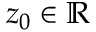Convert formula to latex. <formula><loc_0><loc_0><loc_500><loc_500>z _ { 0 } \in \mathbb { R }</formula> 